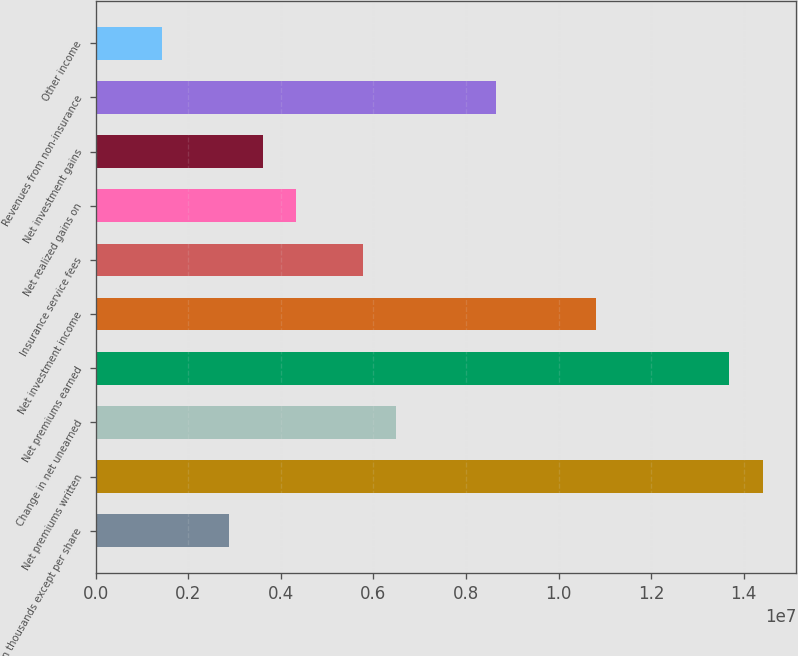Convert chart to OTSL. <chart><loc_0><loc_0><loc_500><loc_500><bar_chart><fcel>(In thousands except per share<fcel>Net premiums written<fcel>Change in net unearned<fcel>Net premiums earned<fcel>Net investment income<fcel>Insurance service fees<fcel>Net realized gains on<fcel>Net investment gains<fcel>Revenues from non-insurance<fcel>Other income<nl><fcel>2.88259e+06<fcel>1.44129e+07<fcel>6.48581e+06<fcel>1.36923e+07<fcel>1.08097e+07<fcel>5.76517e+06<fcel>4.32388e+06<fcel>3.60323e+06<fcel>8.64775e+06<fcel>1.44129e+06<nl></chart> 